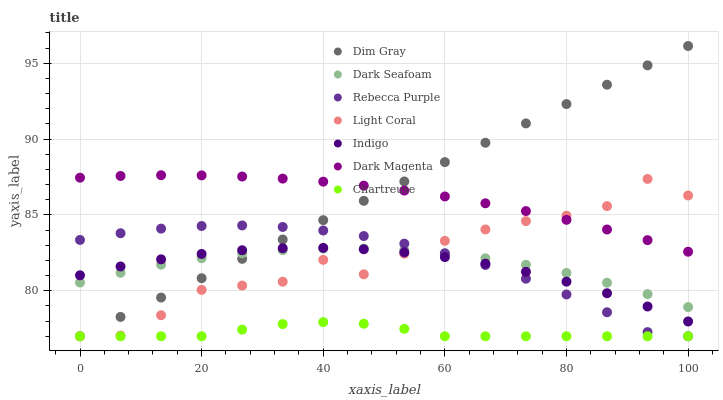Does Chartreuse have the minimum area under the curve?
Answer yes or no. Yes. Does Dim Gray have the maximum area under the curve?
Answer yes or no. Yes. Does Indigo have the minimum area under the curve?
Answer yes or no. No. Does Indigo have the maximum area under the curve?
Answer yes or no. No. Is Dim Gray the smoothest?
Answer yes or no. Yes. Is Light Coral the roughest?
Answer yes or no. Yes. Is Indigo the smoothest?
Answer yes or no. No. Is Indigo the roughest?
Answer yes or no. No. Does Dim Gray have the lowest value?
Answer yes or no. Yes. Does Indigo have the lowest value?
Answer yes or no. No. Does Dim Gray have the highest value?
Answer yes or no. Yes. Does Indigo have the highest value?
Answer yes or no. No. Is Chartreuse less than Dark Seafoam?
Answer yes or no. Yes. Is Dark Magenta greater than Chartreuse?
Answer yes or no. Yes. Does Chartreuse intersect Light Coral?
Answer yes or no. Yes. Is Chartreuse less than Light Coral?
Answer yes or no. No. Is Chartreuse greater than Light Coral?
Answer yes or no. No. Does Chartreuse intersect Dark Seafoam?
Answer yes or no. No. 